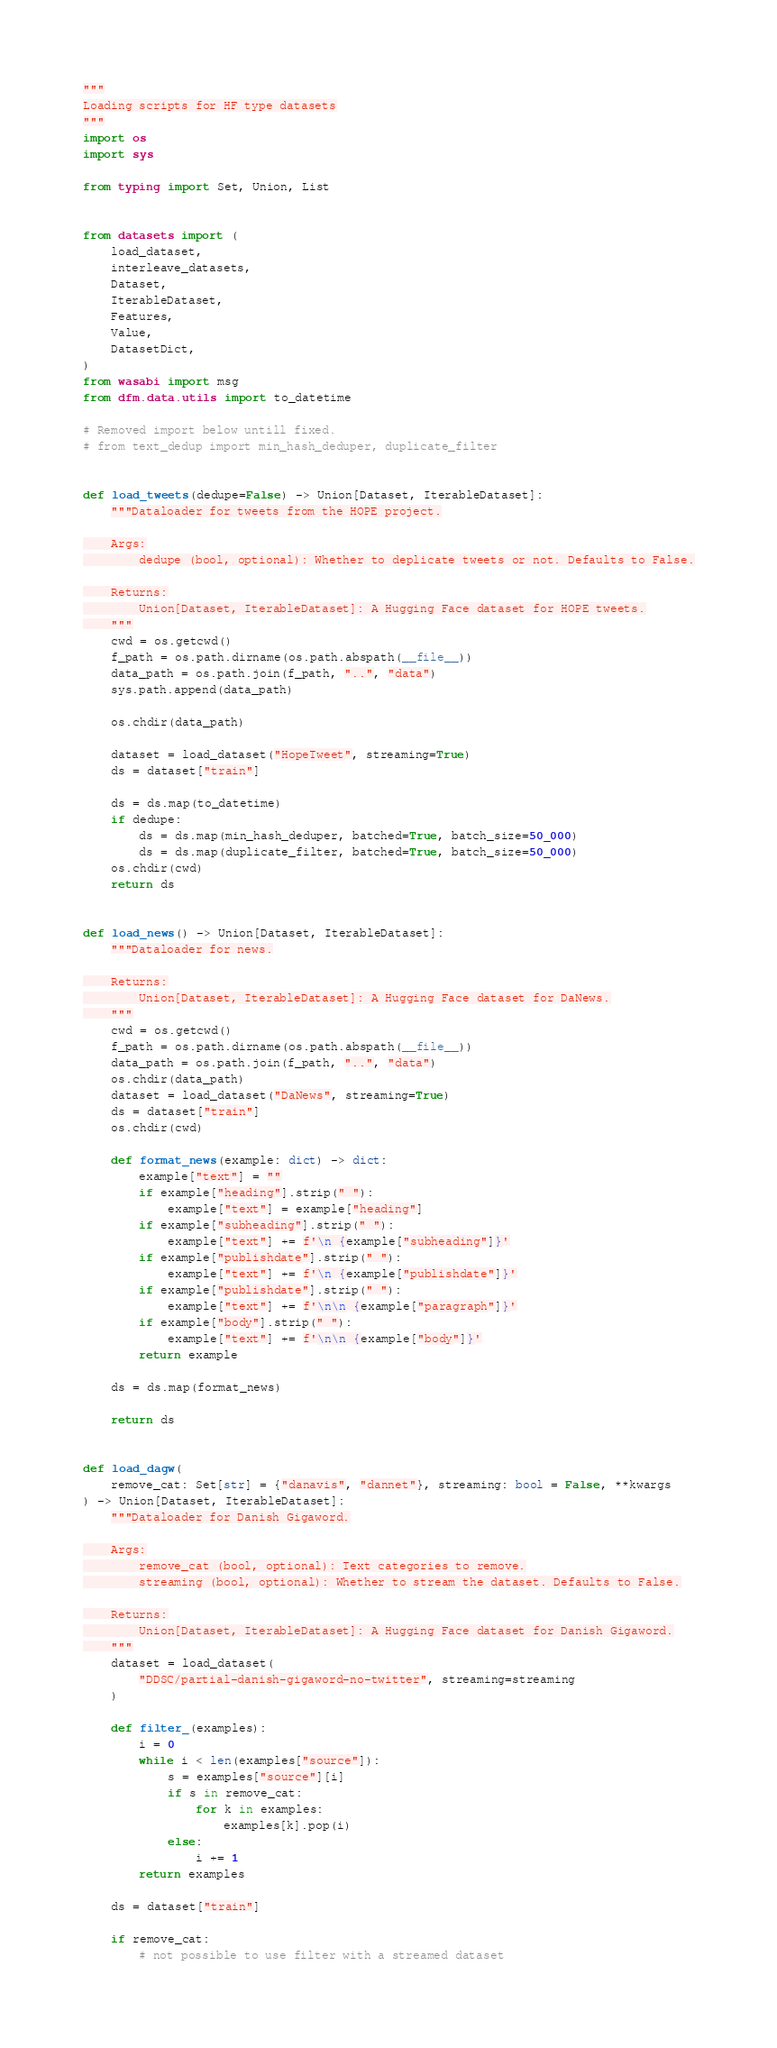Convert code to text. <code><loc_0><loc_0><loc_500><loc_500><_Python_>"""
Loading scripts for HF type datasets
"""
import os
import sys

from typing import Set, Union, List


from datasets import (
    load_dataset,
    interleave_datasets,
    Dataset,
    IterableDataset,
    Features,
    Value,
    DatasetDict,
)
from wasabi import msg
from dfm.data.utils import to_datetime

# Removed import below untill fixed.
# from text_dedup import min_hash_deduper, duplicate_filter


def load_tweets(dedupe=False) -> Union[Dataset, IterableDataset]:
    """Dataloader for tweets from the HOPE project.

    Args:
        dedupe (bool, optional): Whether to deplicate tweets or not. Defaults to False.

    Returns:
        Union[Dataset, IterableDataset]: A Hugging Face dataset for HOPE tweets.
    """
    cwd = os.getcwd()
    f_path = os.path.dirname(os.path.abspath(__file__))
    data_path = os.path.join(f_path, "..", "data")
    sys.path.append(data_path)

    os.chdir(data_path)

    dataset = load_dataset("HopeTweet", streaming=True)
    ds = dataset["train"]

    ds = ds.map(to_datetime)
    if dedupe:
        ds = ds.map(min_hash_deduper, batched=True, batch_size=50_000)
        ds = ds.map(duplicate_filter, batched=True, batch_size=50_000)
    os.chdir(cwd)
    return ds


def load_news() -> Union[Dataset, IterableDataset]:
    """Dataloader for news.

    Returns:
        Union[Dataset, IterableDataset]: A Hugging Face dataset for DaNews.
    """
    cwd = os.getcwd()
    f_path = os.path.dirname(os.path.abspath(__file__))
    data_path = os.path.join(f_path, "..", "data")
    os.chdir(data_path)
    dataset = load_dataset("DaNews", streaming=True)
    ds = dataset["train"]
    os.chdir(cwd)

    def format_news(example: dict) -> dict:
        example["text"] = ""
        if example["heading"].strip(" "):
            example["text"] = example["heading"]
        if example["subheading"].strip(" "):
            example["text"] += f'\n {example["subheading"]}'
        if example["publishdate"].strip(" "):
            example["text"] += f'\n {example["publishdate"]}'
        if example["publishdate"].strip(" "):
            example["text"] += f'\n\n {example["paragraph"]}'
        if example["body"].strip(" "):
            example["text"] += f'\n\n {example["body"]}'
        return example

    ds = ds.map(format_news)

    return ds


def load_dagw(
    remove_cat: Set[str] = {"danavis", "dannet"}, streaming: bool = False, **kwargs
) -> Union[Dataset, IterableDataset]:
    """Dataloader for Danish Gigaword.

    Args:
        remove_cat (bool, optional): Text categories to remove.
        streaming (bool, optional): Whether to stream the dataset. Defaults to False.

    Returns:
        Union[Dataset, IterableDataset]: A Hugging Face dataset for Danish Gigaword.
    """
    dataset = load_dataset(
        "DDSC/partial-danish-gigaword-no-twitter", streaming=streaming
    )

    def filter_(examples):
        i = 0
        while i < len(examples["source"]):
            s = examples["source"][i]
            if s in remove_cat:
                for k in examples:
                    examples[k].pop(i)
            else:
                i += 1
        return examples

    ds = dataset["train"]

    if remove_cat:
        # not possible to use filter with a streamed dataset</code> 